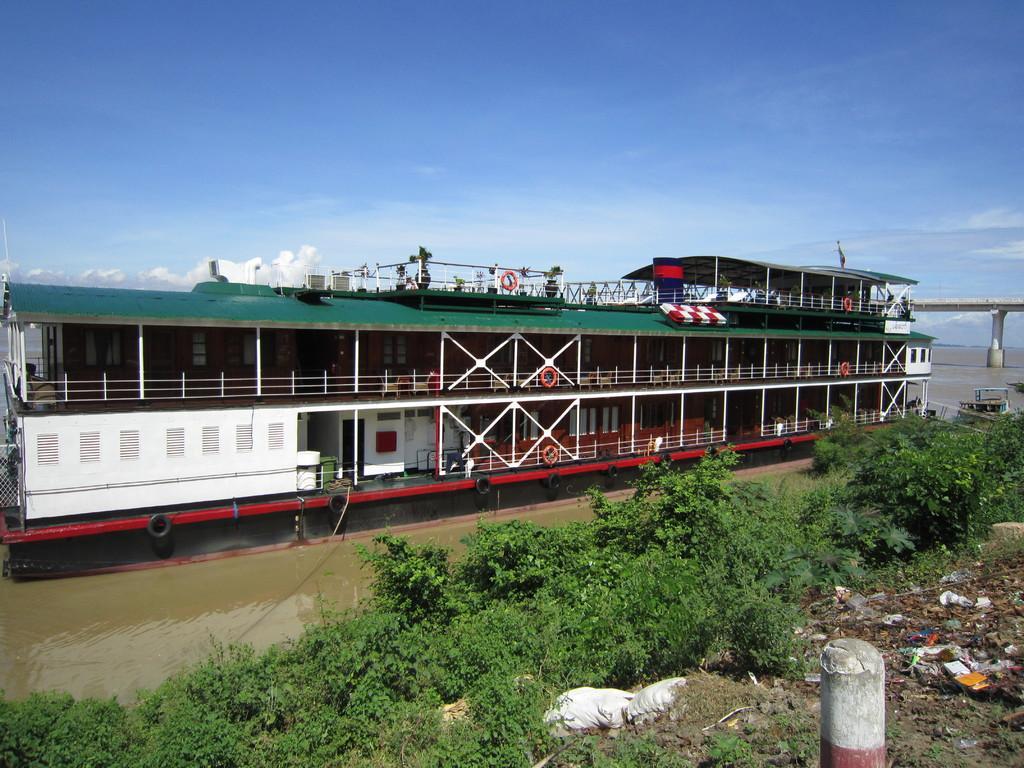Describe this image in one or two sentences. In the image we can see the ship in the water. Here we can see the water, the bridge, grass, garbage and the cloudy sky. 